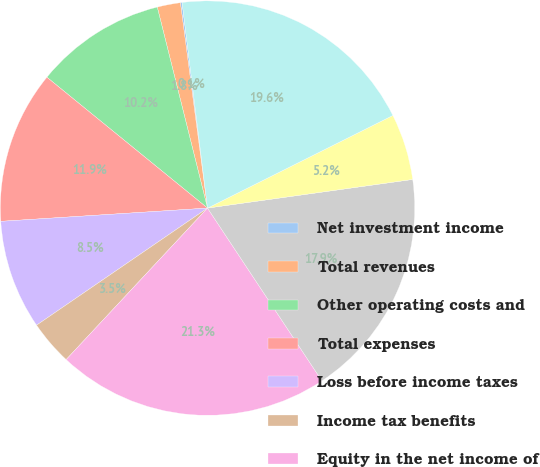Convert chart to OTSL. <chart><loc_0><loc_0><loc_500><loc_500><pie_chart><fcel>Net investment income<fcel>Total revenues<fcel>Other operating costs and<fcel>Total expenses<fcel>Loss before income taxes<fcel>Income tax benefits<fcel>Equity in the net income of<fcel>Income from continuing<fcel>Income from discontinued<fcel>Net income<nl><fcel>0.13%<fcel>1.81%<fcel>10.22%<fcel>11.9%<fcel>8.54%<fcel>3.49%<fcel>21.26%<fcel>17.9%<fcel>5.17%<fcel>19.58%<nl></chart> 